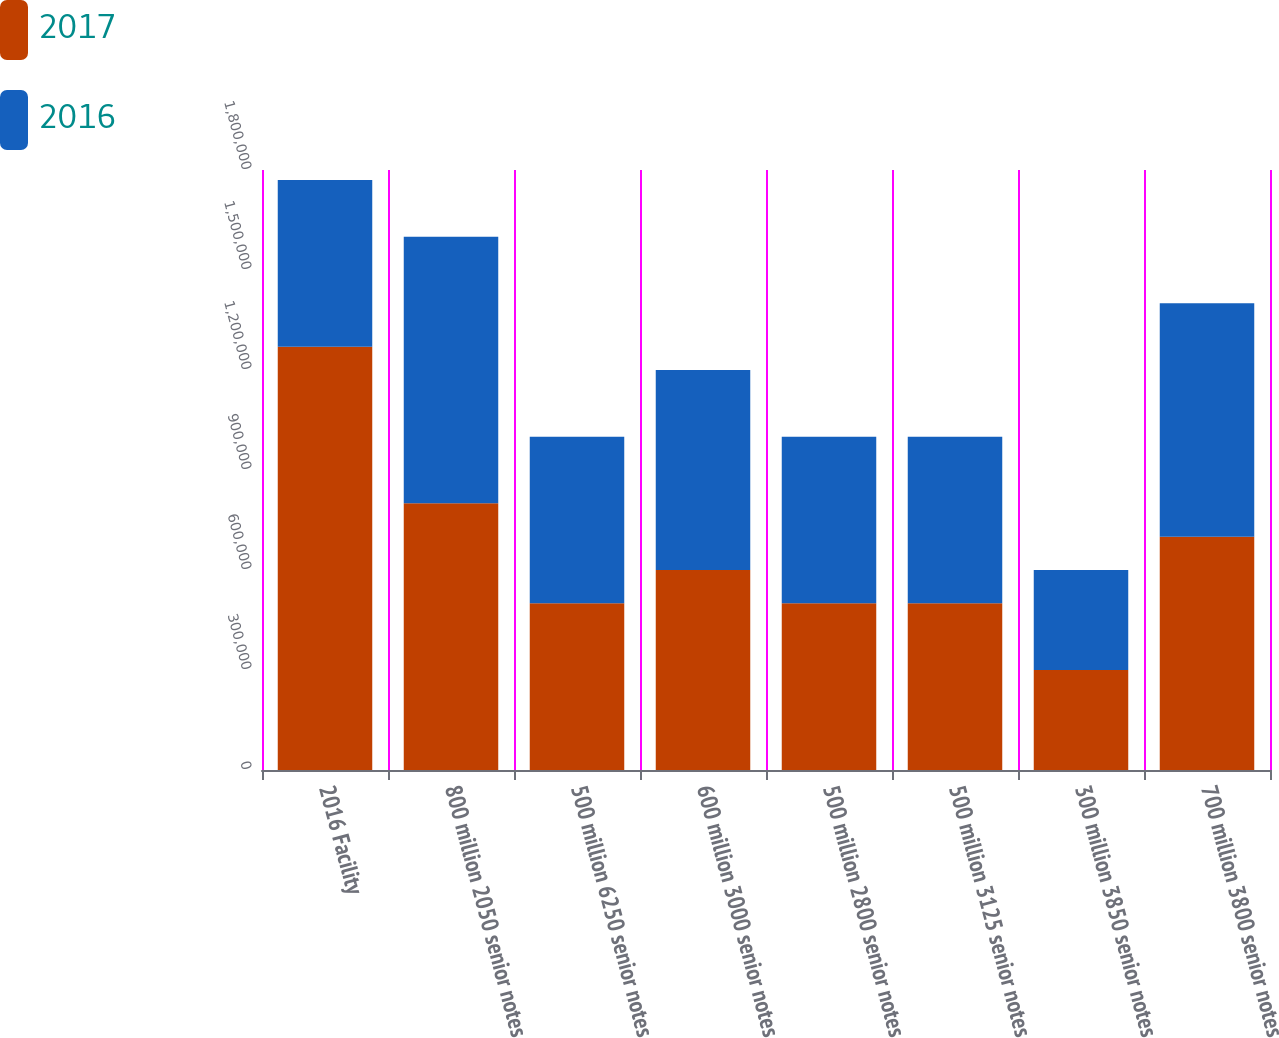<chart> <loc_0><loc_0><loc_500><loc_500><stacked_bar_chart><ecel><fcel>2016 Facility<fcel>800 million 2050 senior notes<fcel>500 million 6250 senior notes<fcel>600 million 3000 senior notes<fcel>500 million 2800 senior notes<fcel>500 million 3125 senior notes<fcel>300 million 3850 senior notes<fcel>700 million 3800 senior notes<nl><fcel>2017<fcel>1.27e+06<fcel>800000<fcel>500000<fcel>600000<fcel>500000<fcel>500000<fcel>300000<fcel>700000<nl><fcel>2016<fcel>500000<fcel>800000<fcel>500000<fcel>600000<fcel>500000<fcel>500000<fcel>300000<fcel>700000<nl></chart> 